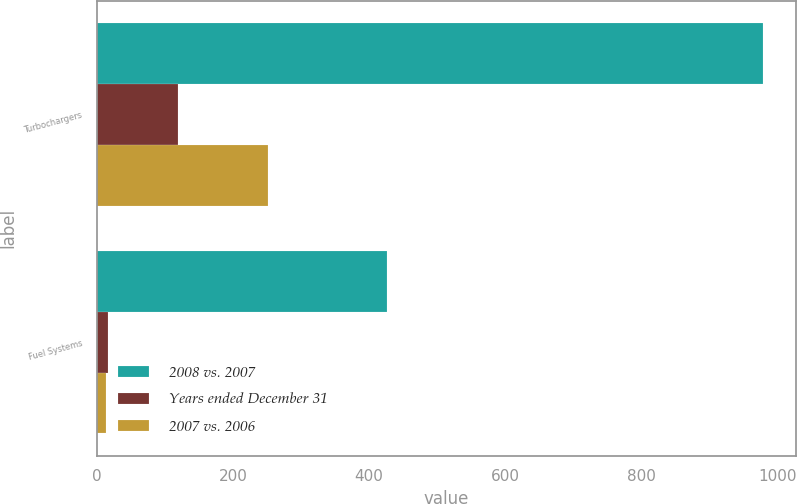Convert chart to OTSL. <chart><loc_0><loc_0><loc_500><loc_500><stacked_bar_chart><ecel><fcel>Turbochargers<fcel>Fuel Systems<nl><fcel>2008 vs. 2007<fcel>979<fcel>426<nl><fcel>Years ended December 31<fcel>119<fcel>17<nl><fcel>2007 vs. 2006<fcel>252<fcel>14<nl></chart> 